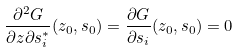<formula> <loc_0><loc_0><loc_500><loc_500>\frac { \partial ^ { 2 } G } { \partial z \partial s ^ { * } _ { i } } ( z _ { 0 } , s _ { 0 } ) = \frac { \partial G } { \partial s _ { i } } ( z _ { 0 } , s _ { 0 } ) = 0</formula> 